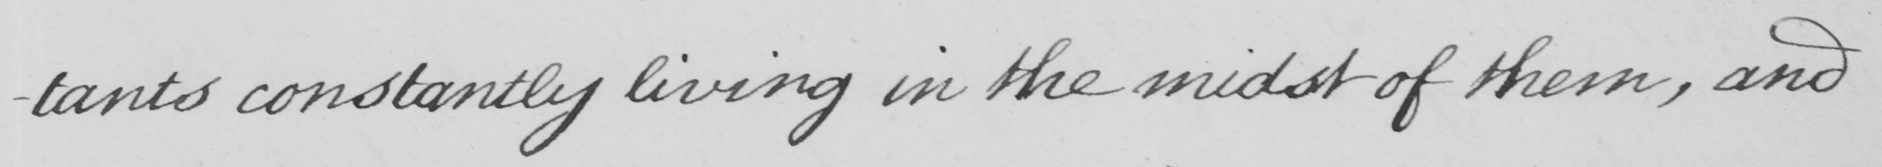Can you read and transcribe this handwriting? -tants constantly living in the midst of them , and 